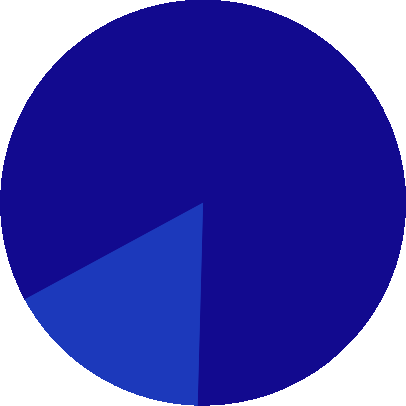<chart> <loc_0><loc_0><loc_500><loc_500><pie_chart><fcel>2004<fcel>2005<nl><fcel>83.33%<fcel>16.67%<nl></chart> 